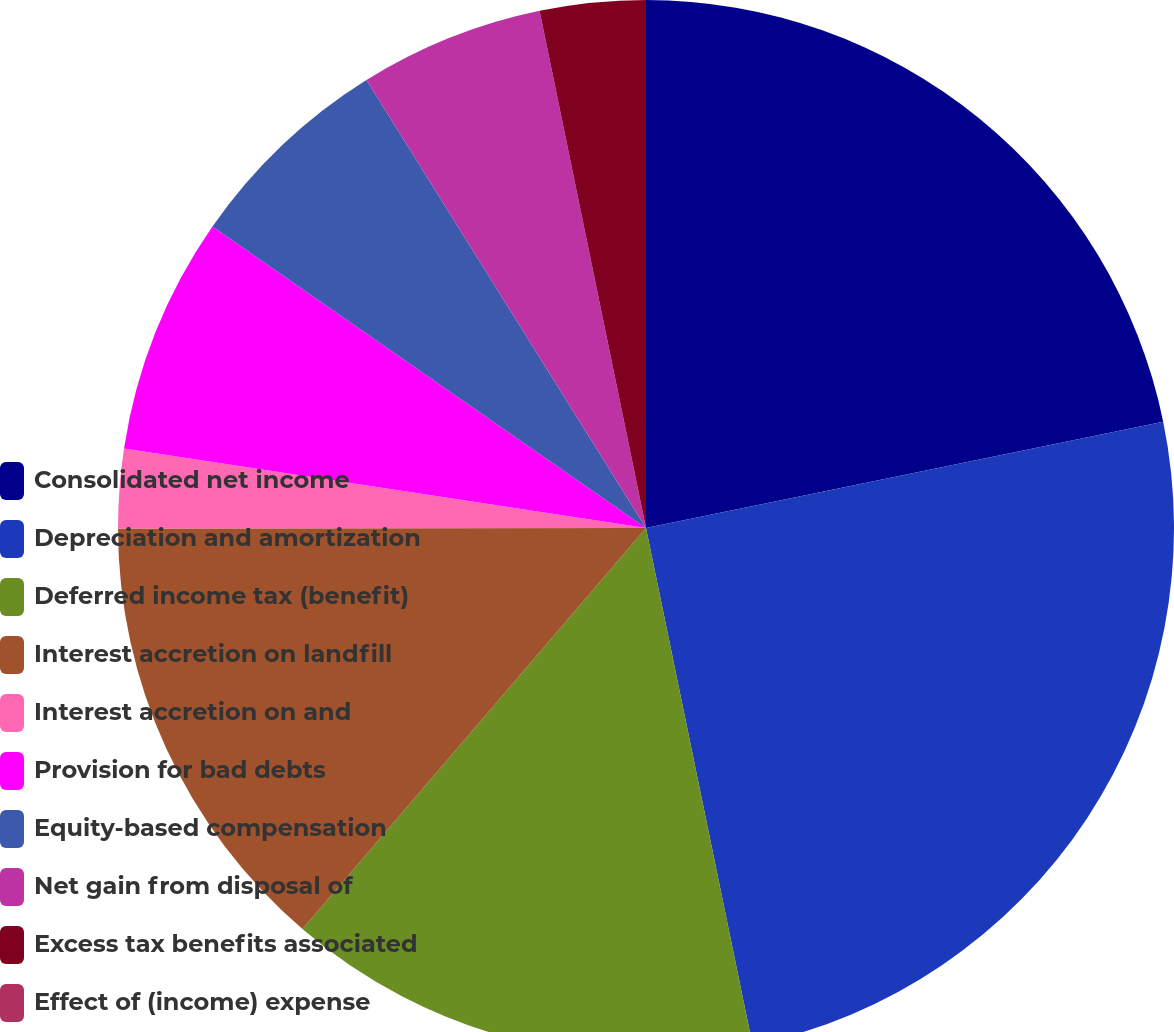Convert chart to OTSL. <chart><loc_0><loc_0><loc_500><loc_500><pie_chart><fcel>Consolidated net income<fcel>Depreciation and amortization<fcel>Deferred income tax (benefit)<fcel>Interest accretion on landfill<fcel>Interest accretion on and<fcel>Provision for bad debts<fcel>Equity-based compensation<fcel>Net gain from disposal of<fcel>Excess tax benefits associated<fcel>Effect of (income) expense<nl><fcel>21.77%<fcel>24.99%<fcel>14.51%<fcel>13.71%<fcel>2.42%<fcel>7.26%<fcel>6.45%<fcel>5.65%<fcel>3.23%<fcel>0.0%<nl></chart> 